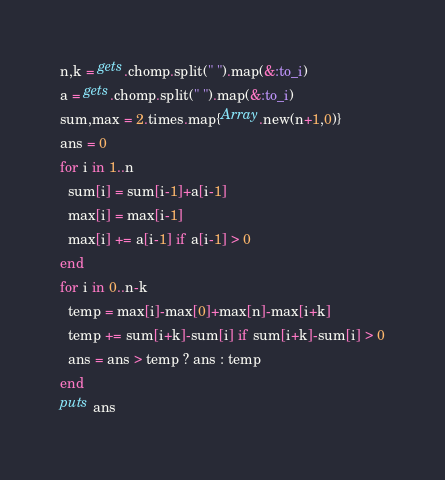Convert code to text. <code><loc_0><loc_0><loc_500><loc_500><_Ruby_>n,k = gets.chomp.split(" ").map(&:to_i)
a = gets.chomp.split(" ").map(&:to_i)
sum,max = 2.times.map{Array.new(n+1,0)}
ans = 0
for i in 1..n
  sum[i] = sum[i-1]+a[i-1]
  max[i] = max[i-1]
  max[i] += a[i-1] if a[i-1] > 0
end
for i in 0..n-k
  temp = max[i]-max[0]+max[n]-max[i+k]
  temp += sum[i+k]-sum[i] if sum[i+k]-sum[i] > 0
  ans = ans > temp ? ans : temp
end
puts ans</code> 